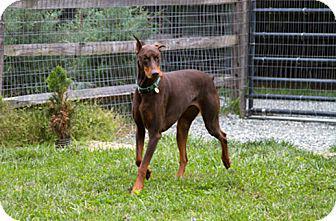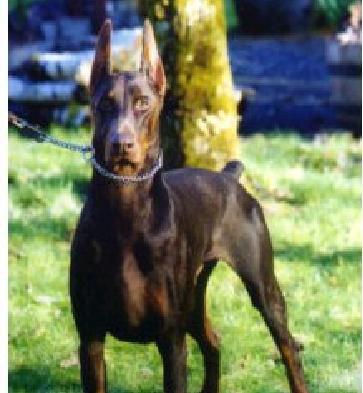The first image is the image on the left, the second image is the image on the right. Given the left and right images, does the statement "One image contains one left-facing doberman with pointy ears and docked tail standing in profile and wearing a vest-type harness." hold true? Answer yes or no. No. The first image is the image on the left, the second image is the image on the right. Assess this claim about the two images: "A black dog is facing left while wearing a harness.". Correct or not? Answer yes or no. No. 